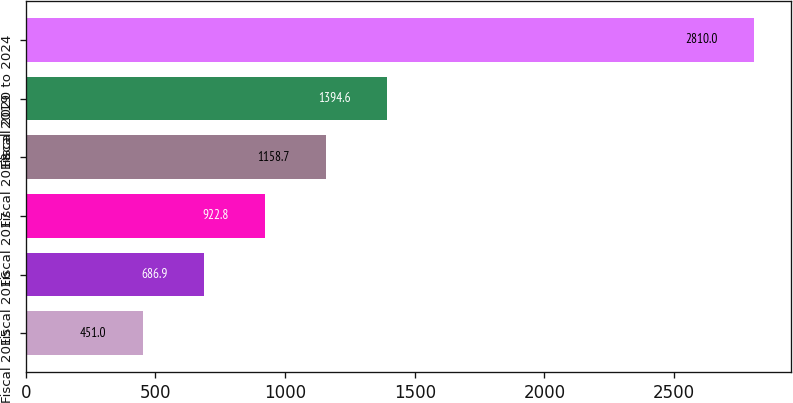Convert chart to OTSL. <chart><loc_0><loc_0><loc_500><loc_500><bar_chart><fcel>Fiscal 2015<fcel>Fiscal 2016<fcel>Fiscal 2017<fcel>Fiscal 2018<fcel>Fiscal 2019<fcel>Fiscal 2020 to 2024<nl><fcel>451<fcel>686.9<fcel>922.8<fcel>1158.7<fcel>1394.6<fcel>2810<nl></chart> 